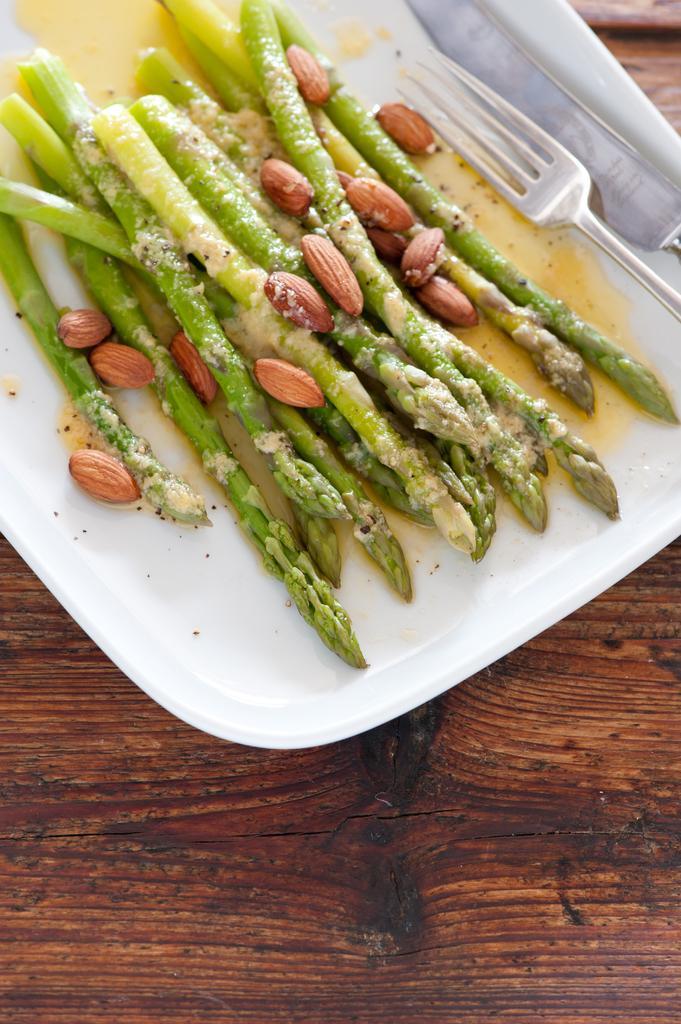Could you give a brief overview of what you see in this image? In this image there is a fork, knife and a food item in a plate which was placed on the wooden table. 